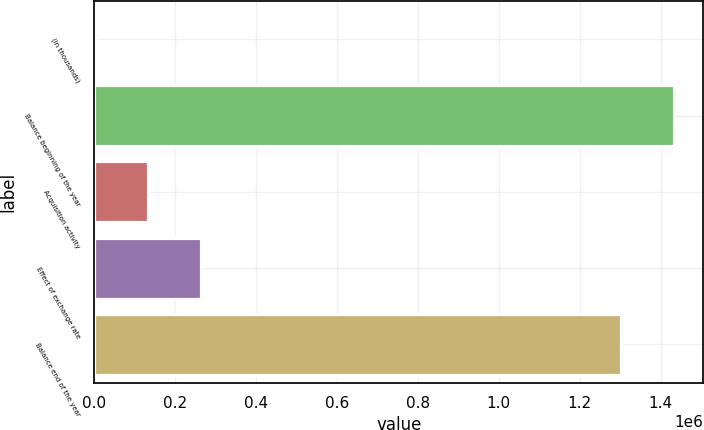<chart> <loc_0><loc_0><loc_500><loc_500><bar_chart><fcel>(in thousands)<fcel>Balance beginning of the year<fcel>Acquisition activity<fcel>Effect of exchange rate<fcel>Balance end of the year<nl><fcel>2010<fcel>1.43411e+06<fcel>133069<fcel>264127<fcel>1.30306e+06<nl></chart> 